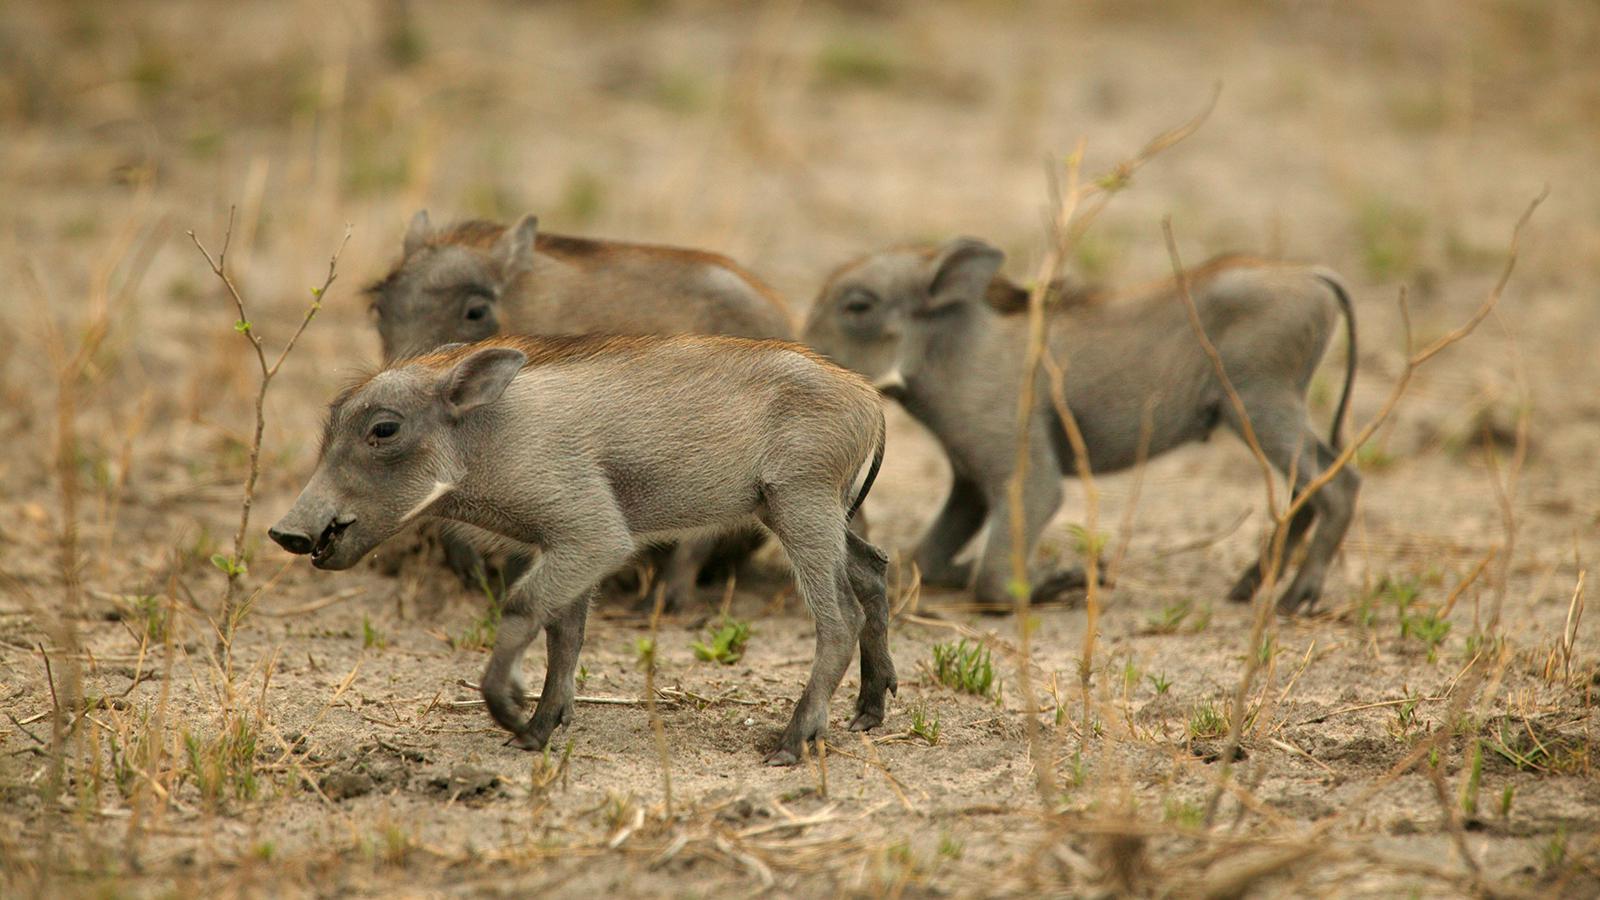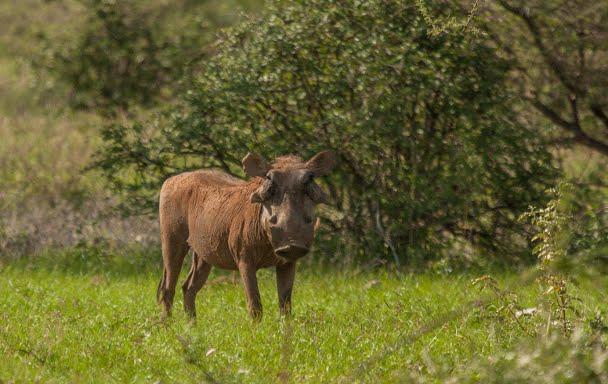The first image is the image on the left, the second image is the image on the right. Evaluate the accuracy of this statement regarding the images: "One image includes a predator of the warthog.". Is it true? Answer yes or no. No. The first image is the image on the left, the second image is the image on the right. Assess this claim about the two images: "there are three baby animals in the image on the right". Correct or not? Answer yes or no. No. 